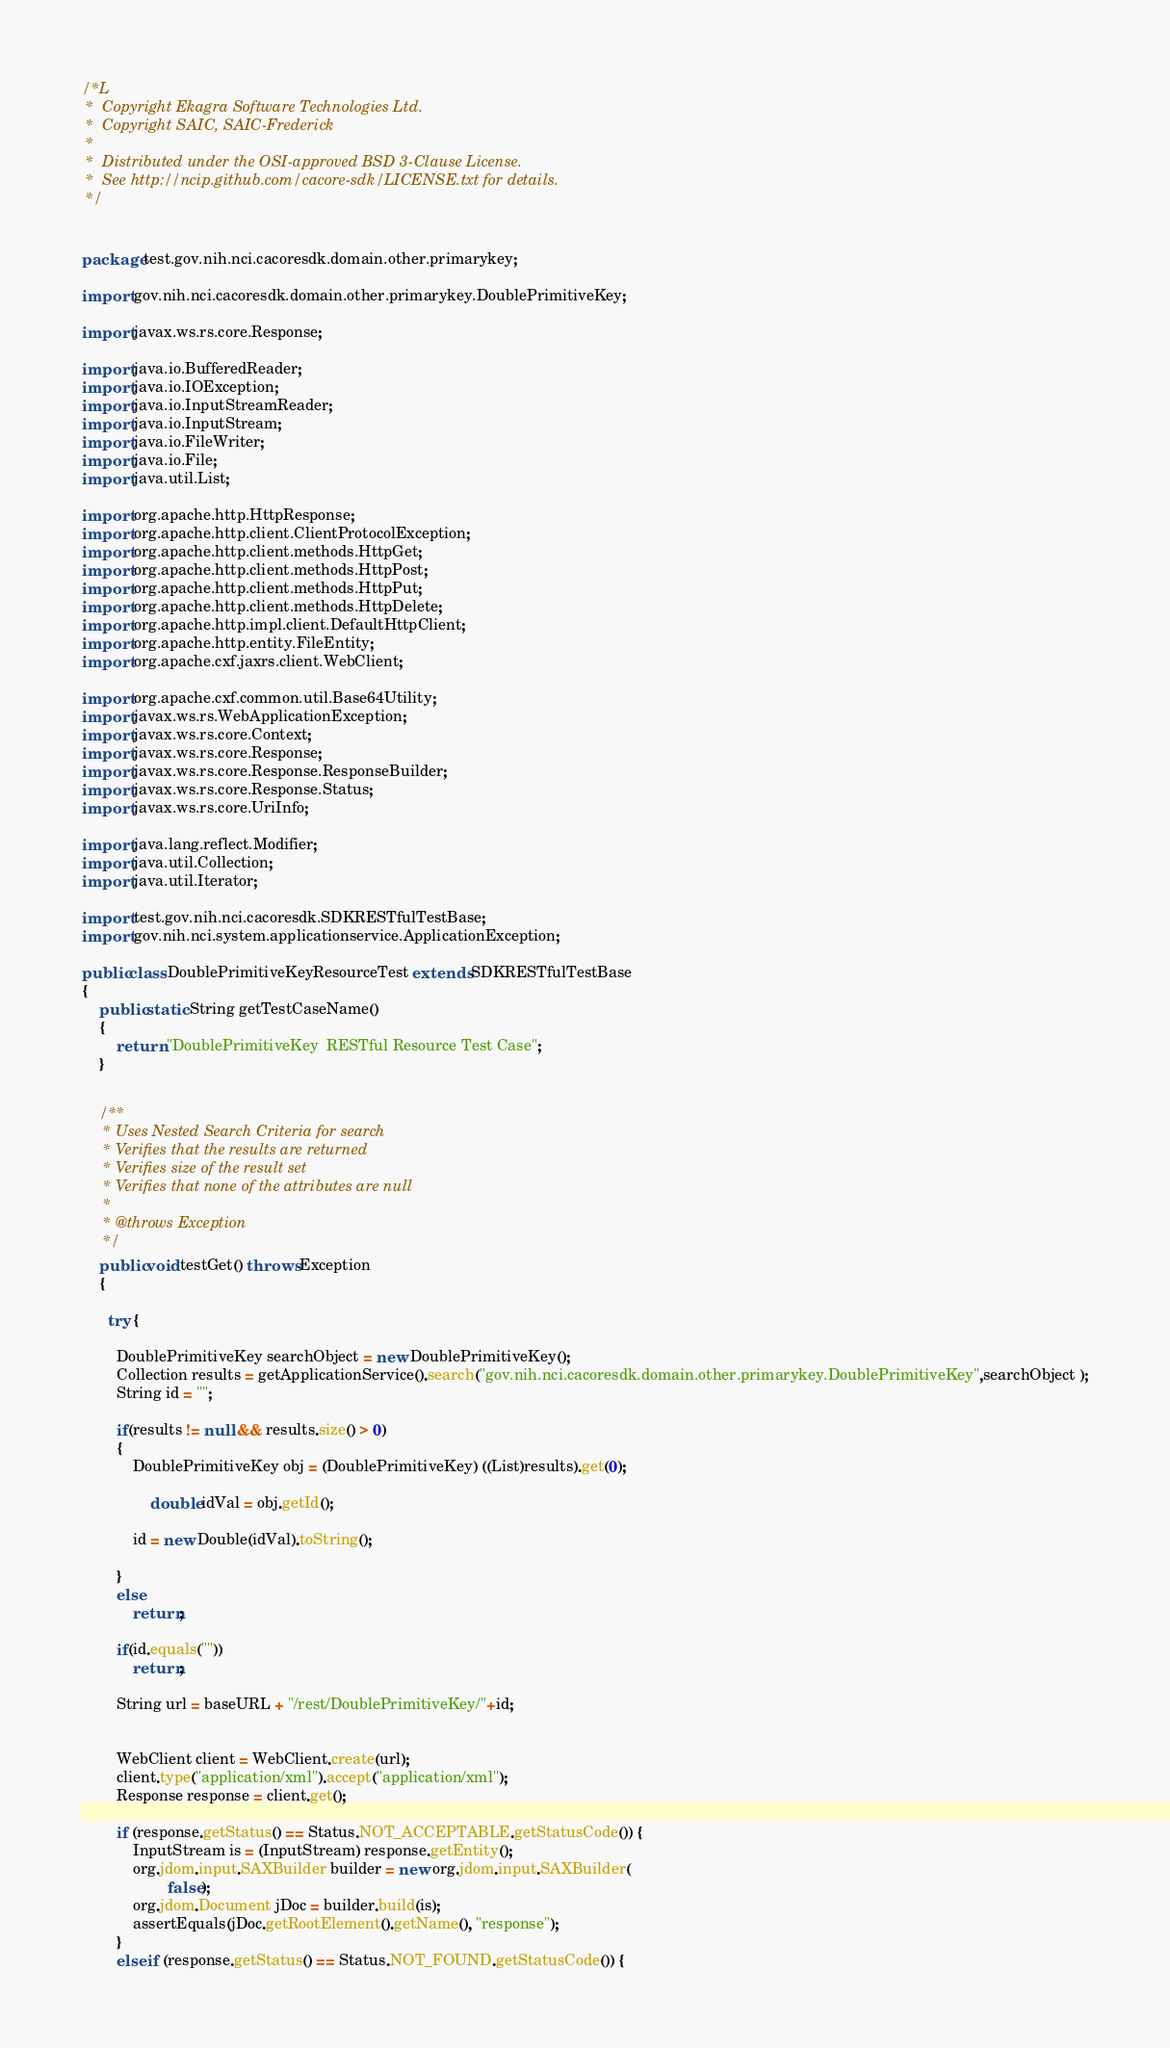Convert code to text. <code><loc_0><loc_0><loc_500><loc_500><_Java_>/*L
 *  Copyright Ekagra Software Technologies Ltd.
 *  Copyright SAIC, SAIC-Frederick
 *
 *  Distributed under the OSI-approved BSD 3-Clause License.
 *  See http://ncip.github.com/cacore-sdk/LICENSE.txt for details.
 */

        
package test.gov.nih.nci.cacoresdk.domain.other.primarykey;

import gov.nih.nci.cacoresdk.domain.other.primarykey.DoublePrimitiveKey;

import javax.ws.rs.core.Response;

import java.io.BufferedReader;
import java.io.IOException;
import java.io.InputStreamReader;
import java.io.InputStream;
import java.io.FileWriter;
import java.io.File;
import java.util.List;

import org.apache.http.HttpResponse;
import org.apache.http.client.ClientProtocolException;
import org.apache.http.client.methods.HttpGet;
import org.apache.http.client.methods.HttpPost;
import org.apache.http.client.methods.HttpPut;
import org.apache.http.client.methods.HttpDelete;
import org.apache.http.impl.client.DefaultHttpClient;
import org.apache.http.entity.FileEntity;
import org.apache.cxf.jaxrs.client.WebClient;

import org.apache.cxf.common.util.Base64Utility;
import javax.ws.rs.WebApplicationException;
import javax.ws.rs.core.Context;
import javax.ws.rs.core.Response;
import javax.ws.rs.core.Response.ResponseBuilder;
import javax.ws.rs.core.Response.Status;
import javax.ws.rs.core.UriInfo;

import java.lang.reflect.Modifier;
import java.util.Collection;
import java.util.Iterator;

import test.gov.nih.nci.cacoresdk.SDKRESTfulTestBase;
import gov.nih.nci.system.applicationservice.ApplicationException;

public class DoublePrimitiveKeyResourceTest extends SDKRESTfulTestBase
{
	public static String getTestCaseName()
	{
		return "DoublePrimitiveKey  RESTful Resource Test Case";
	}

	
	/**
	 * Uses Nested Search Criteria for search
	 * Verifies that the results are returned 
	 * Verifies size of the result set
	 * Verifies that none of the attributes are null
	 * 
	 * @throws Exception
	 */
	public void testGet() throws Exception
	{
		
	  try {
 
 		DoublePrimitiveKey searchObject = new DoublePrimitiveKey();
 		Collection results = getApplicationService().search("gov.nih.nci.cacoresdk.domain.other.primarykey.DoublePrimitiveKey",searchObject );
		String id = "";
		
		if(results != null && results.size() > 0)
		{
			DoublePrimitiveKey obj = (DoublePrimitiveKey) ((List)results).get(0);
		
				double idVal = obj.getId();
			
			id = new Double(idVal).toString();
			
		}
		else
			return;

		if(id.equals(""))
			return;
			
		String url = baseURL + "/rest/DoublePrimitiveKey/"+id;

 
		WebClient client = WebClient.create(url);
		client.type("application/xml").accept("application/xml");		
		Response response = client.get();
 
		if (response.getStatus() == Status.NOT_ACCEPTABLE.getStatusCode()) {
			InputStream is = (InputStream) response.getEntity();
			org.jdom.input.SAXBuilder builder = new org.jdom.input.SAXBuilder(
					false);
			org.jdom.Document jDoc = builder.build(is);
			assertEquals(jDoc.getRootElement().getName(), "response");
		}
		else if (response.getStatus() == Status.NOT_FOUND.getStatusCode()) {</code> 